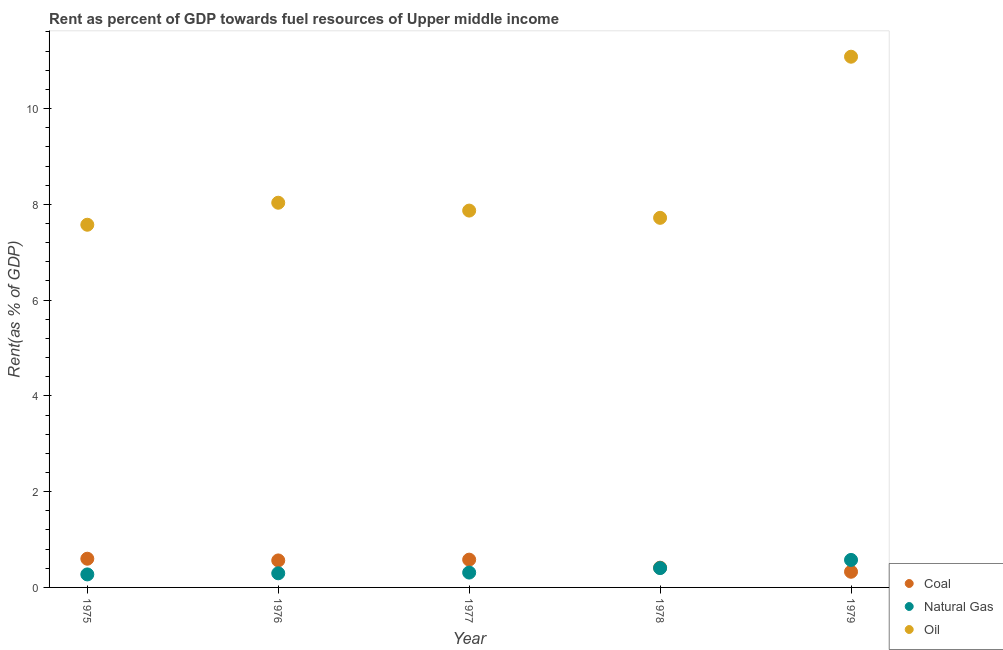How many different coloured dotlines are there?
Keep it short and to the point. 3. What is the rent towards natural gas in 1976?
Your answer should be very brief. 0.3. Across all years, what is the maximum rent towards oil?
Your response must be concise. 11.08. Across all years, what is the minimum rent towards oil?
Offer a very short reply. 7.57. In which year was the rent towards oil maximum?
Provide a succinct answer. 1979. In which year was the rent towards natural gas minimum?
Make the answer very short. 1975. What is the total rent towards natural gas in the graph?
Your answer should be very brief. 1.86. What is the difference between the rent towards coal in 1975 and that in 1979?
Ensure brevity in your answer.  0.27. What is the difference between the rent towards natural gas in 1975 and the rent towards coal in 1977?
Offer a terse response. -0.31. What is the average rent towards natural gas per year?
Ensure brevity in your answer.  0.37. In the year 1978, what is the difference between the rent towards natural gas and rent towards coal?
Ensure brevity in your answer.  -0.01. What is the ratio of the rent towards natural gas in 1975 to that in 1978?
Make the answer very short. 0.67. Is the difference between the rent towards natural gas in 1976 and 1977 greater than the difference between the rent towards coal in 1976 and 1977?
Provide a short and direct response. Yes. What is the difference between the highest and the second highest rent towards natural gas?
Your answer should be compact. 0.17. What is the difference between the highest and the lowest rent towards natural gas?
Keep it short and to the point. 0.3. In how many years, is the rent towards oil greater than the average rent towards oil taken over all years?
Offer a very short reply. 1. Is the sum of the rent towards natural gas in 1975 and 1979 greater than the maximum rent towards coal across all years?
Offer a terse response. Yes. Does the rent towards oil monotonically increase over the years?
Give a very brief answer. No. Is the rent towards oil strictly less than the rent towards natural gas over the years?
Your answer should be compact. No. How many years are there in the graph?
Provide a short and direct response. 5. How are the legend labels stacked?
Offer a very short reply. Vertical. What is the title of the graph?
Keep it short and to the point. Rent as percent of GDP towards fuel resources of Upper middle income. Does "Nuclear sources" appear as one of the legend labels in the graph?
Ensure brevity in your answer.  No. What is the label or title of the X-axis?
Offer a terse response. Year. What is the label or title of the Y-axis?
Provide a short and direct response. Rent(as % of GDP). What is the Rent(as % of GDP) in Coal in 1975?
Your answer should be compact. 0.6. What is the Rent(as % of GDP) of Natural Gas in 1975?
Provide a short and direct response. 0.27. What is the Rent(as % of GDP) in Oil in 1975?
Your answer should be very brief. 7.57. What is the Rent(as % of GDP) in Coal in 1976?
Give a very brief answer. 0.56. What is the Rent(as % of GDP) in Natural Gas in 1976?
Your response must be concise. 0.3. What is the Rent(as % of GDP) in Oil in 1976?
Your answer should be very brief. 8.03. What is the Rent(as % of GDP) of Coal in 1977?
Offer a very short reply. 0.58. What is the Rent(as % of GDP) of Natural Gas in 1977?
Provide a short and direct response. 0.31. What is the Rent(as % of GDP) of Oil in 1977?
Your response must be concise. 7.87. What is the Rent(as % of GDP) in Coal in 1978?
Provide a short and direct response. 0.41. What is the Rent(as % of GDP) of Natural Gas in 1978?
Make the answer very short. 0.4. What is the Rent(as % of GDP) of Oil in 1978?
Give a very brief answer. 7.72. What is the Rent(as % of GDP) of Coal in 1979?
Offer a very short reply. 0.33. What is the Rent(as % of GDP) of Natural Gas in 1979?
Give a very brief answer. 0.57. What is the Rent(as % of GDP) of Oil in 1979?
Your answer should be very brief. 11.08. Across all years, what is the maximum Rent(as % of GDP) of Coal?
Your answer should be compact. 0.6. Across all years, what is the maximum Rent(as % of GDP) in Natural Gas?
Ensure brevity in your answer.  0.57. Across all years, what is the maximum Rent(as % of GDP) in Oil?
Provide a short and direct response. 11.08. Across all years, what is the minimum Rent(as % of GDP) of Coal?
Keep it short and to the point. 0.33. Across all years, what is the minimum Rent(as % of GDP) in Natural Gas?
Your response must be concise. 0.27. Across all years, what is the minimum Rent(as % of GDP) in Oil?
Make the answer very short. 7.57. What is the total Rent(as % of GDP) in Coal in the graph?
Your answer should be compact. 2.48. What is the total Rent(as % of GDP) of Natural Gas in the graph?
Your answer should be very brief. 1.86. What is the total Rent(as % of GDP) of Oil in the graph?
Offer a very short reply. 42.28. What is the difference between the Rent(as % of GDP) of Coal in 1975 and that in 1976?
Your answer should be compact. 0.04. What is the difference between the Rent(as % of GDP) of Natural Gas in 1975 and that in 1976?
Keep it short and to the point. -0.02. What is the difference between the Rent(as % of GDP) of Oil in 1975 and that in 1976?
Provide a succinct answer. -0.46. What is the difference between the Rent(as % of GDP) of Coal in 1975 and that in 1977?
Offer a terse response. 0.02. What is the difference between the Rent(as % of GDP) in Natural Gas in 1975 and that in 1977?
Give a very brief answer. -0.04. What is the difference between the Rent(as % of GDP) in Oil in 1975 and that in 1977?
Make the answer very short. -0.3. What is the difference between the Rent(as % of GDP) of Coal in 1975 and that in 1978?
Offer a terse response. 0.19. What is the difference between the Rent(as % of GDP) of Natural Gas in 1975 and that in 1978?
Your answer should be compact. -0.13. What is the difference between the Rent(as % of GDP) in Oil in 1975 and that in 1978?
Your answer should be compact. -0.14. What is the difference between the Rent(as % of GDP) of Coal in 1975 and that in 1979?
Give a very brief answer. 0.27. What is the difference between the Rent(as % of GDP) in Natural Gas in 1975 and that in 1979?
Provide a short and direct response. -0.3. What is the difference between the Rent(as % of GDP) of Oil in 1975 and that in 1979?
Ensure brevity in your answer.  -3.51. What is the difference between the Rent(as % of GDP) in Coal in 1976 and that in 1977?
Your answer should be very brief. -0.02. What is the difference between the Rent(as % of GDP) in Natural Gas in 1976 and that in 1977?
Make the answer very short. -0.01. What is the difference between the Rent(as % of GDP) of Oil in 1976 and that in 1977?
Your answer should be compact. 0.16. What is the difference between the Rent(as % of GDP) in Coal in 1976 and that in 1978?
Ensure brevity in your answer.  0.15. What is the difference between the Rent(as % of GDP) in Natural Gas in 1976 and that in 1978?
Offer a terse response. -0.11. What is the difference between the Rent(as % of GDP) of Oil in 1976 and that in 1978?
Provide a succinct answer. 0.32. What is the difference between the Rent(as % of GDP) in Coal in 1976 and that in 1979?
Your response must be concise. 0.24. What is the difference between the Rent(as % of GDP) in Natural Gas in 1976 and that in 1979?
Keep it short and to the point. -0.28. What is the difference between the Rent(as % of GDP) of Oil in 1976 and that in 1979?
Your answer should be very brief. -3.05. What is the difference between the Rent(as % of GDP) in Coal in 1977 and that in 1978?
Provide a succinct answer. 0.17. What is the difference between the Rent(as % of GDP) of Natural Gas in 1977 and that in 1978?
Your answer should be very brief. -0.09. What is the difference between the Rent(as % of GDP) of Oil in 1977 and that in 1978?
Give a very brief answer. 0.15. What is the difference between the Rent(as % of GDP) of Coal in 1977 and that in 1979?
Provide a short and direct response. 0.25. What is the difference between the Rent(as % of GDP) of Natural Gas in 1977 and that in 1979?
Ensure brevity in your answer.  -0.26. What is the difference between the Rent(as % of GDP) in Oil in 1977 and that in 1979?
Your response must be concise. -3.21. What is the difference between the Rent(as % of GDP) in Coal in 1978 and that in 1979?
Make the answer very short. 0.09. What is the difference between the Rent(as % of GDP) in Natural Gas in 1978 and that in 1979?
Give a very brief answer. -0.17. What is the difference between the Rent(as % of GDP) of Oil in 1978 and that in 1979?
Provide a short and direct response. -3.37. What is the difference between the Rent(as % of GDP) of Coal in 1975 and the Rent(as % of GDP) of Natural Gas in 1976?
Your answer should be compact. 0.3. What is the difference between the Rent(as % of GDP) in Coal in 1975 and the Rent(as % of GDP) in Oil in 1976?
Offer a very short reply. -7.43. What is the difference between the Rent(as % of GDP) of Natural Gas in 1975 and the Rent(as % of GDP) of Oil in 1976?
Your answer should be compact. -7.76. What is the difference between the Rent(as % of GDP) in Coal in 1975 and the Rent(as % of GDP) in Natural Gas in 1977?
Offer a terse response. 0.29. What is the difference between the Rent(as % of GDP) in Coal in 1975 and the Rent(as % of GDP) in Oil in 1977?
Provide a short and direct response. -7.27. What is the difference between the Rent(as % of GDP) of Natural Gas in 1975 and the Rent(as % of GDP) of Oil in 1977?
Offer a very short reply. -7.6. What is the difference between the Rent(as % of GDP) of Coal in 1975 and the Rent(as % of GDP) of Natural Gas in 1978?
Your response must be concise. 0.2. What is the difference between the Rent(as % of GDP) of Coal in 1975 and the Rent(as % of GDP) of Oil in 1978?
Your answer should be very brief. -7.12. What is the difference between the Rent(as % of GDP) of Natural Gas in 1975 and the Rent(as % of GDP) of Oil in 1978?
Offer a terse response. -7.45. What is the difference between the Rent(as % of GDP) of Coal in 1975 and the Rent(as % of GDP) of Natural Gas in 1979?
Make the answer very short. 0.03. What is the difference between the Rent(as % of GDP) in Coal in 1975 and the Rent(as % of GDP) in Oil in 1979?
Ensure brevity in your answer.  -10.48. What is the difference between the Rent(as % of GDP) of Natural Gas in 1975 and the Rent(as % of GDP) of Oil in 1979?
Give a very brief answer. -10.81. What is the difference between the Rent(as % of GDP) of Coal in 1976 and the Rent(as % of GDP) of Natural Gas in 1977?
Give a very brief answer. 0.25. What is the difference between the Rent(as % of GDP) of Coal in 1976 and the Rent(as % of GDP) of Oil in 1977?
Your answer should be compact. -7.31. What is the difference between the Rent(as % of GDP) in Natural Gas in 1976 and the Rent(as % of GDP) in Oil in 1977?
Your answer should be very brief. -7.58. What is the difference between the Rent(as % of GDP) in Coal in 1976 and the Rent(as % of GDP) in Natural Gas in 1978?
Keep it short and to the point. 0.16. What is the difference between the Rent(as % of GDP) of Coal in 1976 and the Rent(as % of GDP) of Oil in 1978?
Your response must be concise. -7.15. What is the difference between the Rent(as % of GDP) in Natural Gas in 1976 and the Rent(as % of GDP) in Oil in 1978?
Your answer should be compact. -7.42. What is the difference between the Rent(as % of GDP) of Coal in 1976 and the Rent(as % of GDP) of Natural Gas in 1979?
Offer a very short reply. -0.01. What is the difference between the Rent(as % of GDP) in Coal in 1976 and the Rent(as % of GDP) in Oil in 1979?
Give a very brief answer. -10.52. What is the difference between the Rent(as % of GDP) in Natural Gas in 1976 and the Rent(as % of GDP) in Oil in 1979?
Keep it short and to the point. -10.79. What is the difference between the Rent(as % of GDP) of Coal in 1977 and the Rent(as % of GDP) of Natural Gas in 1978?
Your answer should be very brief. 0.18. What is the difference between the Rent(as % of GDP) in Coal in 1977 and the Rent(as % of GDP) in Oil in 1978?
Provide a succinct answer. -7.14. What is the difference between the Rent(as % of GDP) of Natural Gas in 1977 and the Rent(as % of GDP) of Oil in 1978?
Keep it short and to the point. -7.41. What is the difference between the Rent(as % of GDP) of Coal in 1977 and the Rent(as % of GDP) of Natural Gas in 1979?
Make the answer very short. 0.01. What is the difference between the Rent(as % of GDP) in Coal in 1977 and the Rent(as % of GDP) in Oil in 1979?
Make the answer very short. -10.5. What is the difference between the Rent(as % of GDP) of Natural Gas in 1977 and the Rent(as % of GDP) of Oil in 1979?
Your answer should be compact. -10.77. What is the difference between the Rent(as % of GDP) of Coal in 1978 and the Rent(as % of GDP) of Natural Gas in 1979?
Keep it short and to the point. -0.16. What is the difference between the Rent(as % of GDP) of Coal in 1978 and the Rent(as % of GDP) of Oil in 1979?
Offer a very short reply. -10.67. What is the difference between the Rent(as % of GDP) of Natural Gas in 1978 and the Rent(as % of GDP) of Oil in 1979?
Ensure brevity in your answer.  -10.68. What is the average Rent(as % of GDP) in Coal per year?
Make the answer very short. 0.5. What is the average Rent(as % of GDP) of Natural Gas per year?
Make the answer very short. 0.37. What is the average Rent(as % of GDP) of Oil per year?
Make the answer very short. 8.46. In the year 1975, what is the difference between the Rent(as % of GDP) of Coal and Rent(as % of GDP) of Natural Gas?
Your answer should be compact. 0.33. In the year 1975, what is the difference between the Rent(as % of GDP) of Coal and Rent(as % of GDP) of Oil?
Your answer should be very brief. -6.98. In the year 1975, what is the difference between the Rent(as % of GDP) of Natural Gas and Rent(as % of GDP) of Oil?
Your answer should be very brief. -7.3. In the year 1976, what is the difference between the Rent(as % of GDP) in Coal and Rent(as % of GDP) in Natural Gas?
Keep it short and to the point. 0.27. In the year 1976, what is the difference between the Rent(as % of GDP) of Coal and Rent(as % of GDP) of Oil?
Your answer should be compact. -7.47. In the year 1976, what is the difference between the Rent(as % of GDP) of Natural Gas and Rent(as % of GDP) of Oil?
Your answer should be compact. -7.74. In the year 1977, what is the difference between the Rent(as % of GDP) of Coal and Rent(as % of GDP) of Natural Gas?
Ensure brevity in your answer.  0.27. In the year 1977, what is the difference between the Rent(as % of GDP) of Coal and Rent(as % of GDP) of Oil?
Keep it short and to the point. -7.29. In the year 1977, what is the difference between the Rent(as % of GDP) in Natural Gas and Rent(as % of GDP) in Oil?
Offer a terse response. -7.56. In the year 1978, what is the difference between the Rent(as % of GDP) of Coal and Rent(as % of GDP) of Natural Gas?
Make the answer very short. 0.01. In the year 1978, what is the difference between the Rent(as % of GDP) in Coal and Rent(as % of GDP) in Oil?
Keep it short and to the point. -7.31. In the year 1978, what is the difference between the Rent(as % of GDP) of Natural Gas and Rent(as % of GDP) of Oil?
Keep it short and to the point. -7.31. In the year 1979, what is the difference between the Rent(as % of GDP) in Coal and Rent(as % of GDP) in Natural Gas?
Your answer should be very brief. -0.25. In the year 1979, what is the difference between the Rent(as % of GDP) of Coal and Rent(as % of GDP) of Oil?
Your response must be concise. -10.76. In the year 1979, what is the difference between the Rent(as % of GDP) of Natural Gas and Rent(as % of GDP) of Oil?
Your response must be concise. -10.51. What is the ratio of the Rent(as % of GDP) of Coal in 1975 to that in 1976?
Your answer should be very brief. 1.06. What is the ratio of the Rent(as % of GDP) of Natural Gas in 1975 to that in 1976?
Make the answer very short. 0.92. What is the ratio of the Rent(as % of GDP) in Oil in 1975 to that in 1976?
Your response must be concise. 0.94. What is the ratio of the Rent(as % of GDP) in Coal in 1975 to that in 1977?
Keep it short and to the point. 1.03. What is the ratio of the Rent(as % of GDP) in Natural Gas in 1975 to that in 1977?
Your response must be concise. 0.88. What is the ratio of the Rent(as % of GDP) of Oil in 1975 to that in 1977?
Offer a very short reply. 0.96. What is the ratio of the Rent(as % of GDP) of Coal in 1975 to that in 1978?
Make the answer very short. 1.45. What is the ratio of the Rent(as % of GDP) of Natural Gas in 1975 to that in 1978?
Your response must be concise. 0.67. What is the ratio of the Rent(as % of GDP) of Oil in 1975 to that in 1978?
Ensure brevity in your answer.  0.98. What is the ratio of the Rent(as % of GDP) of Coal in 1975 to that in 1979?
Provide a short and direct response. 1.83. What is the ratio of the Rent(as % of GDP) in Natural Gas in 1975 to that in 1979?
Ensure brevity in your answer.  0.47. What is the ratio of the Rent(as % of GDP) of Oil in 1975 to that in 1979?
Give a very brief answer. 0.68. What is the ratio of the Rent(as % of GDP) of Coal in 1976 to that in 1977?
Your answer should be very brief. 0.97. What is the ratio of the Rent(as % of GDP) of Natural Gas in 1976 to that in 1977?
Ensure brevity in your answer.  0.95. What is the ratio of the Rent(as % of GDP) of Oil in 1976 to that in 1977?
Provide a short and direct response. 1.02. What is the ratio of the Rent(as % of GDP) in Coal in 1976 to that in 1978?
Your answer should be compact. 1.37. What is the ratio of the Rent(as % of GDP) of Natural Gas in 1976 to that in 1978?
Make the answer very short. 0.73. What is the ratio of the Rent(as % of GDP) in Oil in 1976 to that in 1978?
Provide a short and direct response. 1.04. What is the ratio of the Rent(as % of GDP) in Coal in 1976 to that in 1979?
Ensure brevity in your answer.  1.72. What is the ratio of the Rent(as % of GDP) of Natural Gas in 1976 to that in 1979?
Provide a short and direct response. 0.51. What is the ratio of the Rent(as % of GDP) of Oil in 1976 to that in 1979?
Ensure brevity in your answer.  0.72. What is the ratio of the Rent(as % of GDP) in Coal in 1977 to that in 1978?
Offer a very short reply. 1.41. What is the ratio of the Rent(as % of GDP) in Natural Gas in 1977 to that in 1978?
Provide a short and direct response. 0.77. What is the ratio of the Rent(as % of GDP) of Oil in 1977 to that in 1978?
Offer a very short reply. 1.02. What is the ratio of the Rent(as % of GDP) of Coal in 1977 to that in 1979?
Your answer should be compact. 1.77. What is the ratio of the Rent(as % of GDP) in Natural Gas in 1977 to that in 1979?
Offer a terse response. 0.54. What is the ratio of the Rent(as % of GDP) of Oil in 1977 to that in 1979?
Keep it short and to the point. 0.71. What is the ratio of the Rent(as % of GDP) of Coal in 1978 to that in 1979?
Ensure brevity in your answer.  1.26. What is the ratio of the Rent(as % of GDP) in Natural Gas in 1978 to that in 1979?
Provide a succinct answer. 0.7. What is the ratio of the Rent(as % of GDP) of Oil in 1978 to that in 1979?
Provide a succinct answer. 0.7. What is the difference between the highest and the second highest Rent(as % of GDP) in Coal?
Keep it short and to the point. 0.02. What is the difference between the highest and the second highest Rent(as % of GDP) of Natural Gas?
Give a very brief answer. 0.17. What is the difference between the highest and the second highest Rent(as % of GDP) of Oil?
Offer a very short reply. 3.05. What is the difference between the highest and the lowest Rent(as % of GDP) in Coal?
Your answer should be very brief. 0.27. What is the difference between the highest and the lowest Rent(as % of GDP) in Natural Gas?
Give a very brief answer. 0.3. What is the difference between the highest and the lowest Rent(as % of GDP) in Oil?
Ensure brevity in your answer.  3.51. 